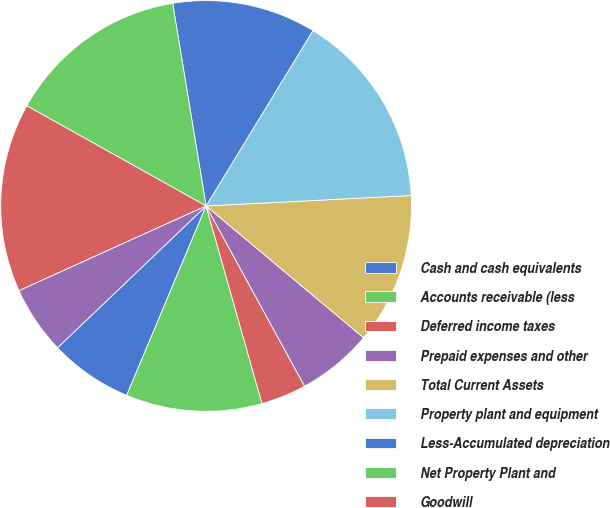Convert chart to OTSL. <chart><loc_0><loc_0><loc_500><loc_500><pie_chart><fcel>Cash and cash equivalents<fcel>Accounts receivable (less<fcel>Deferred income taxes<fcel>Prepaid expenses and other<fcel>Total Current Assets<fcel>Property plant and equipment<fcel>Less-Accumulated depreciation<fcel>Net Property Plant and<fcel>Goodwill<fcel>Customer relationships and<nl><fcel>6.55%<fcel>10.71%<fcel>3.57%<fcel>5.95%<fcel>11.9%<fcel>15.48%<fcel>11.31%<fcel>14.29%<fcel>14.88%<fcel>5.36%<nl></chart> 